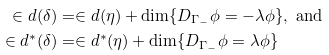<formula> <loc_0><loc_0><loc_500><loc_500>\in d ( \delta ) & = \in d ( \eta ) + \dim \{ D _ { \Gamma _ { - } } \phi = - \lambda \phi \} , \text { and} \\ \in d ^ { * } ( \delta ) & = \in d ^ { * } ( \eta ) + \dim \{ D _ { \Gamma _ { - } } \phi = \lambda \phi \}</formula> 